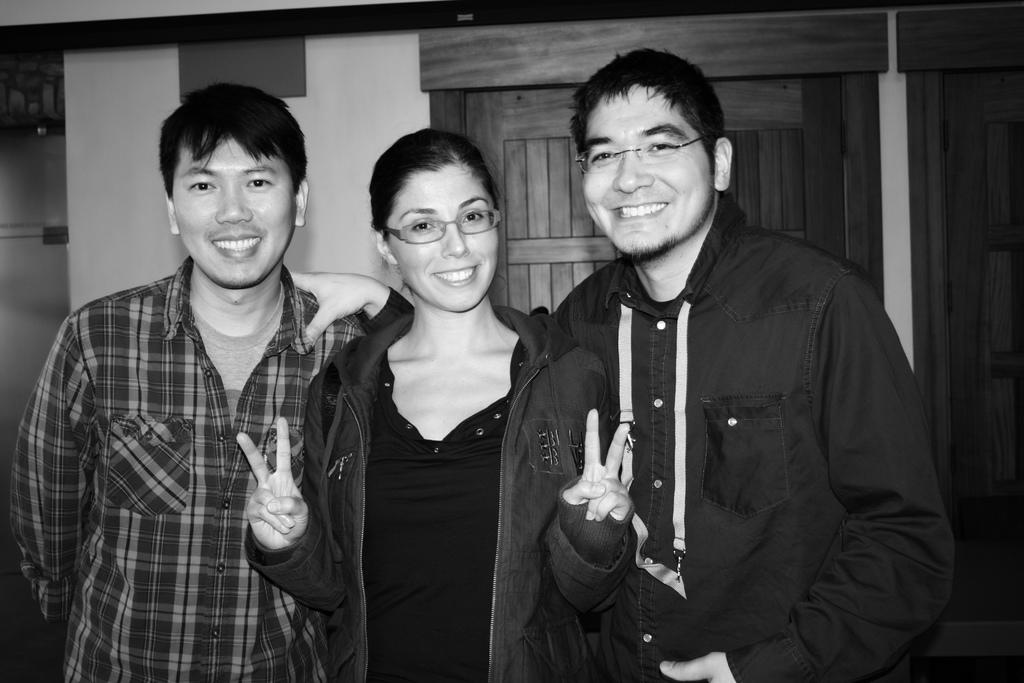How many people are in the image? There are three people in the image. What is the facial expression of the people in the image? The people are smiling. What can be seen in the background of the image? There is a wall and doors in the background of the image. What type of disease is affecting the people in the image? There is no indication of any disease affecting the people in the image; they are smiling and appear healthy. 